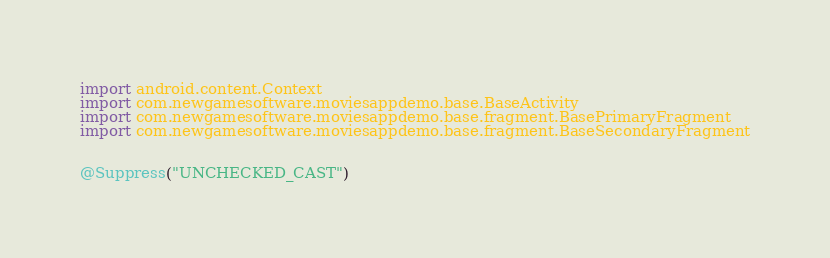Convert code to text. <code><loc_0><loc_0><loc_500><loc_500><_Kotlin_>import android.content.Context
import com.newgamesoftware.moviesappdemo.base.BaseActivity
import com.newgamesoftware.moviesappdemo.base.fragment.BasePrimaryFragment
import com.newgamesoftware.moviesappdemo.base.fragment.BaseSecondaryFragment


@Suppress("UNCHECKED_CAST")</code> 